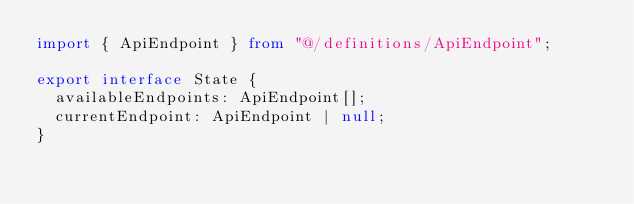Convert code to text. <code><loc_0><loc_0><loc_500><loc_500><_TypeScript_>import { ApiEndpoint } from "@/definitions/ApiEndpoint";

export interface State {
  availableEndpoints: ApiEndpoint[];
  currentEndpoint: ApiEndpoint | null;
}
</code> 